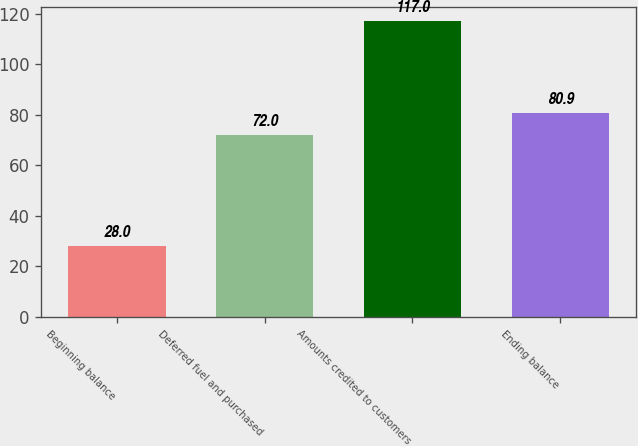Convert chart to OTSL. <chart><loc_0><loc_0><loc_500><loc_500><bar_chart><fcel>Beginning balance<fcel>Deferred fuel and purchased<fcel>Amounts credited to customers<fcel>Ending balance<nl><fcel>28<fcel>72<fcel>117<fcel>80.9<nl></chart> 